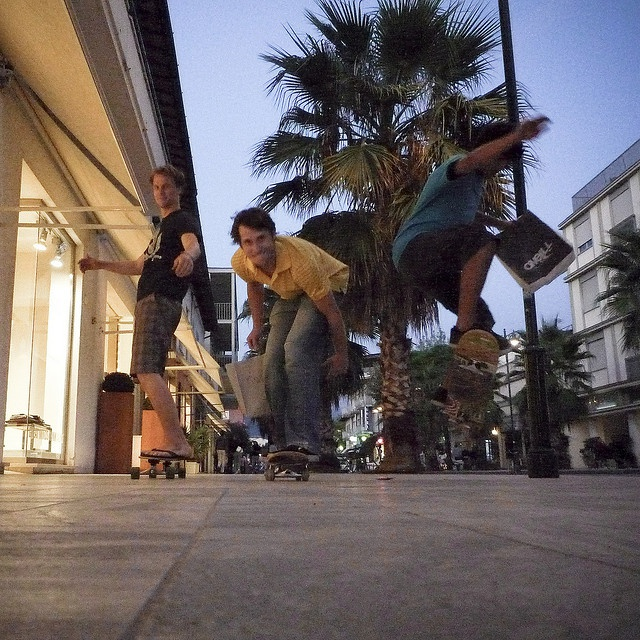Describe the objects in this image and their specific colors. I can see people in tan, black, maroon, and gray tones, people in tan, black, maroon, and gray tones, people in tan, black, maroon, and brown tones, skateboard in tan, black, maroon, and gray tones, and handbag in tan, black, and gray tones in this image. 